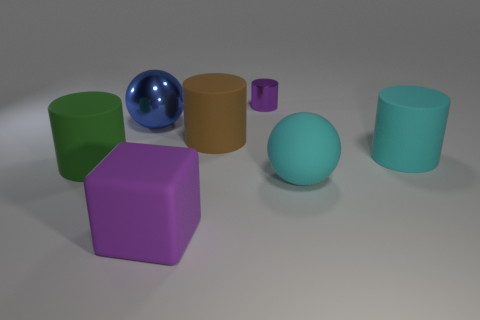Subtract all big cyan cylinders. How many cylinders are left? 3 Add 1 metallic things. How many objects exist? 8 Subtract all green cylinders. How many cylinders are left? 3 Subtract 2 cylinders. How many cylinders are left? 2 Add 3 big rubber cubes. How many big rubber cubes are left? 4 Add 7 blue metallic spheres. How many blue metallic spheres exist? 8 Subtract 1 cyan balls. How many objects are left? 6 Subtract all cubes. How many objects are left? 6 Subtract all gray cylinders. Subtract all purple spheres. How many cylinders are left? 4 Subtract all brown rubber cylinders. Subtract all blue things. How many objects are left? 5 